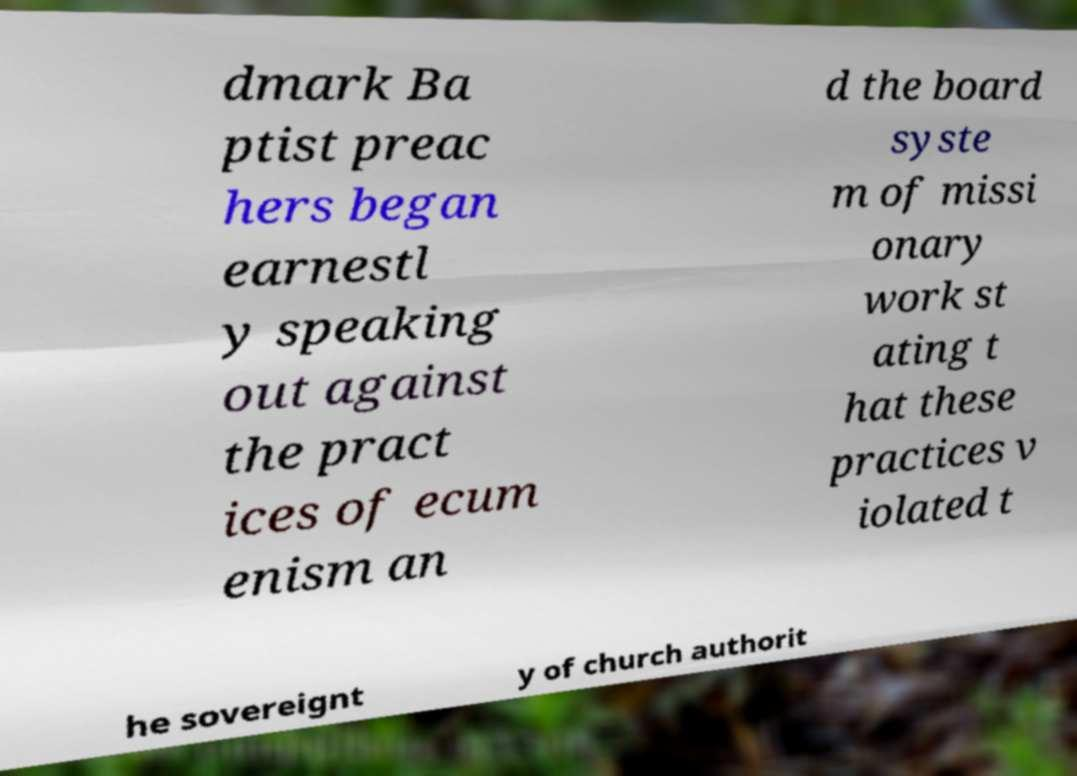Could you assist in decoding the text presented in this image and type it out clearly? dmark Ba ptist preac hers began earnestl y speaking out against the pract ices of ecum enism an d the board syste m of missi onary work st ating t hat these practices v iolated t he sovereignt y of church authorit 